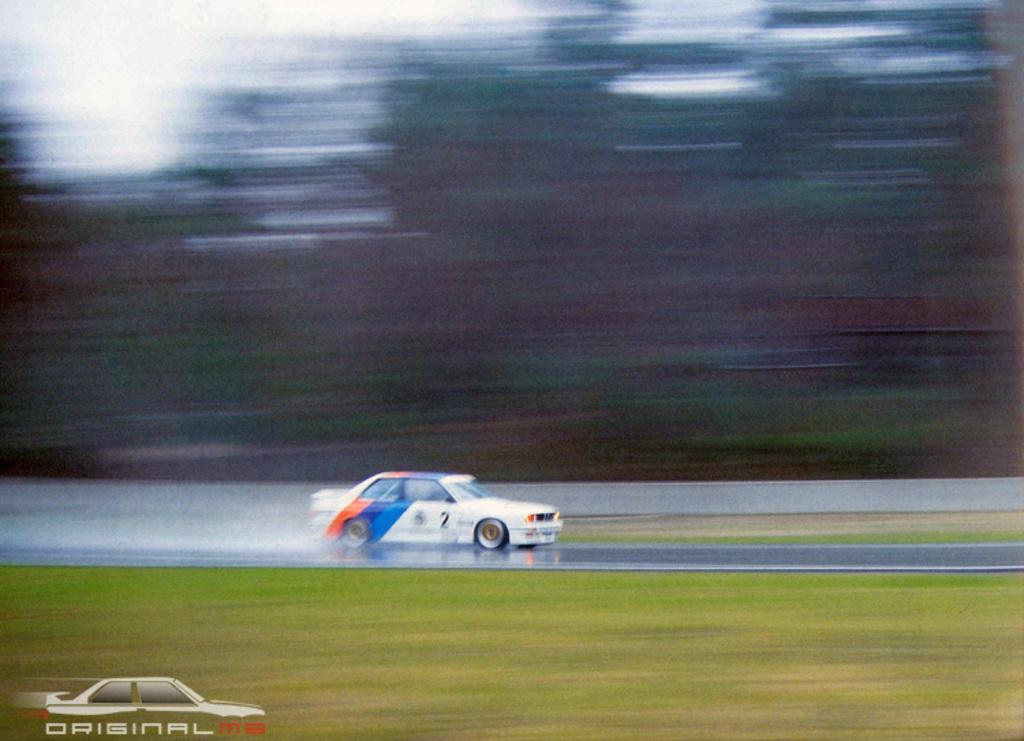What type of vehicle is in the image? There is a white car in the image. What is located at the bottom of the image? There is a road at the bottom of the image. What color is the grass visible in the image? Green grass is visible in the image. What can be seen in the background of the image? There are trees in the background of the image. How is the background of the image depicted? The background is blurred. What type of watch is the judge wearing in the image? There is no judge or watch present in the image; it features a white car, a road, green grass, trees, and a blurred background. Is there a stove visible in the image? No, there is no stove present in the image. 